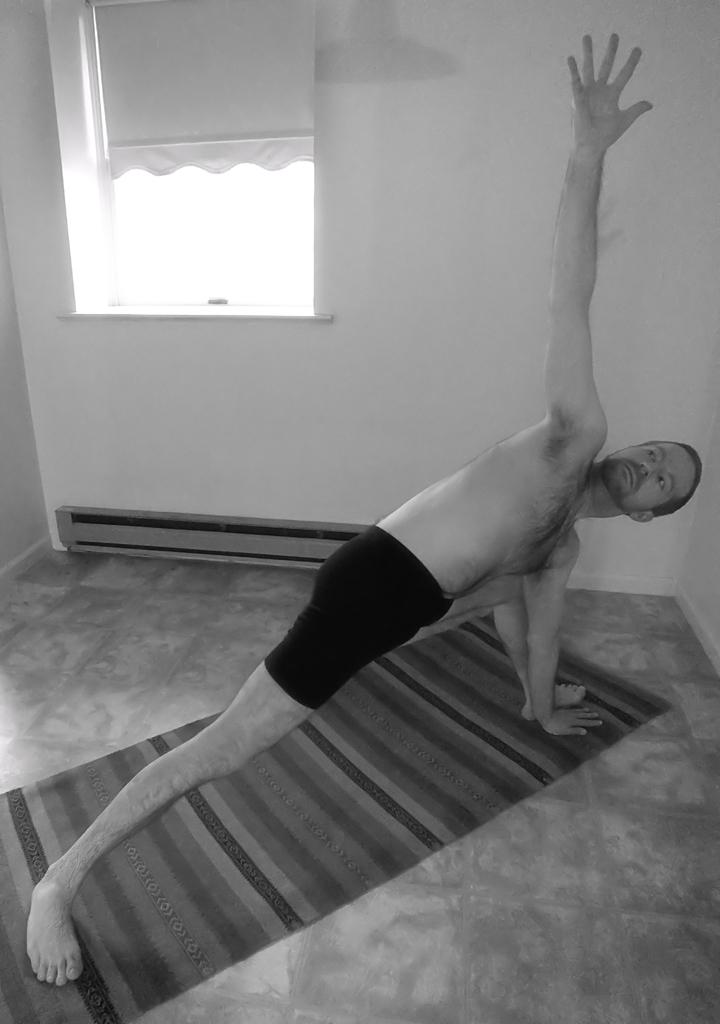What is the person in the image doing? The person in the image is doing exercises. Where is the person doing the exercises? The person is on the floor. What can be seen in the background of the image? There is a window and a wall in the background of the image. What does the person's father believe about the exercises in the image? There is no information about the person's father or their beliefs in the image. 